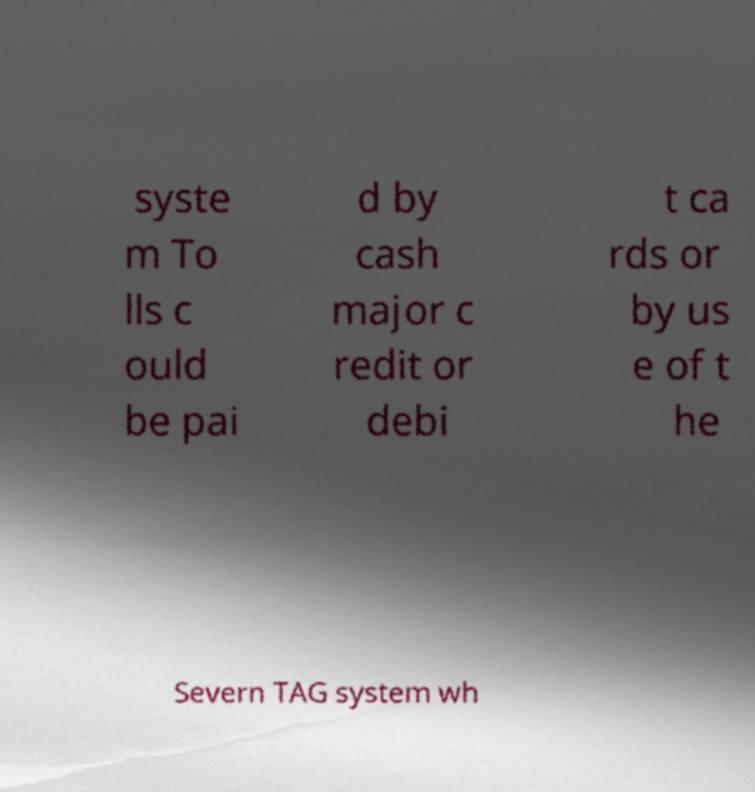Could you assist in decoding the text presented in this image and type it out clearly? syste m To lls c ould be pai d by cash major c redit or debi t ca rds or by us e of t he Severn TAG system wh 